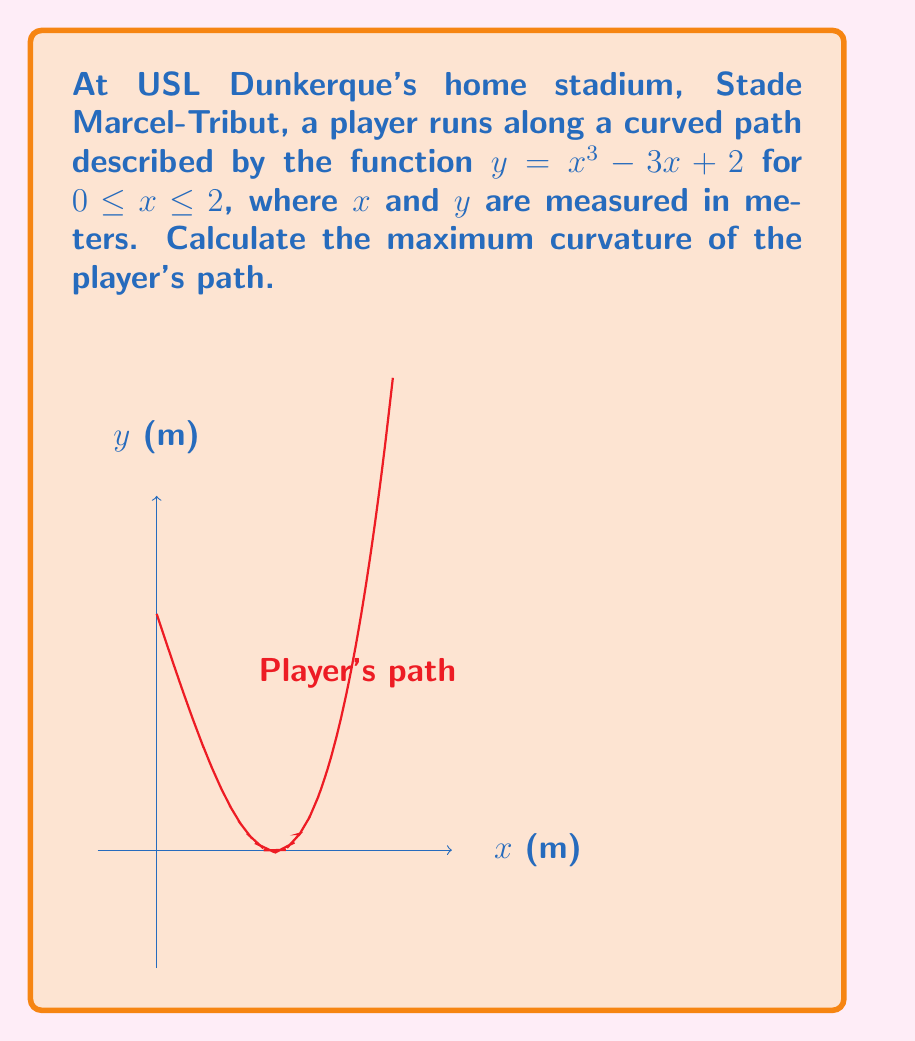Teach me how to tackle this problem. To find the maximum curvature, we'll follow these steps:

1) The curvature formula for a function $y = f(x)$ is:

   $$\kappa = \frac{|f''(x)|}{(1 + [f'(x)]^2)^{3/2}}$$

2) First, let's find $f'(x)$ and $f''(x)$:
   
   $f'(x) = 3x^2 - 3$
   $f''(x) = 6x$

3) Now, let's substitute these into the curvature formula:

   $$\kappa = \frac{|6x|}{(1 + (3x^2 - 3)^2)^{3/2}}$$

4) To find the maximum curvature, we need to find where the derivative of $\kappa$ with respect to $x$ is zero. However, this leads to a complex equation. Instead, we can observe that the maximum curvature will occur where $|f''(x)|$ is largest and $1 + [f'(x)]^2$ is smallest.

5) $|f''(x)| = |6x|$ is largest at $x = 2$ (the upper bound of our interval).

6) $1 + [f'(x)]^2 = 1 + (3x^2 - 3)^2$ is smallest when $3x^2 - 3 = 0$, or $x = 1$.

7) Since these don't occur at the same $x$ value, we need to check both $x = 1$ and $x = 2$:

   At $x = 1$: $\kappa = \frac{|6|}{(1 + 0^2)^{3/2}} = 6$

   At $x = 2$: $\kappa = \frac{|12|}{(1 + 9^2)^{3/2}} \approx 0.1304$

8) The maximum curvature occurs at $x = 1$ with a value of 6.
Answer: 6 m^(-1) 